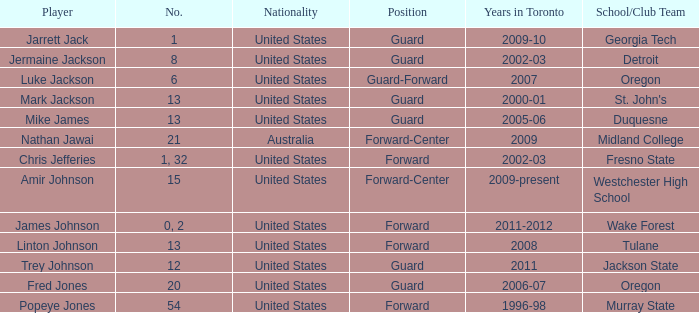What are the total amount of numbers on the Toronto team in 2005-06? 1.0. Could you parse the entire table as a dict? {'header': ['Player', 'No.', 'Nationality', 'Position', 'Years in Toronto', 'School/Club Team'], 'rows': [['Jarrett Jack', '1', 'United States', 'Guard', '2009-10', 'Georgia Tech'], ['Jermaine Jackson', '8', 'United States', 'Guard', '2002-03', 'Detroit'], ['Luke Jackson', '6', 'United States', 'Guard-Forward', '2007', 'Oregon'], ['Mark Jackson', '13', 'United States', 'Guard', '2000-01', "St. John's"], ['Mike James', '13', 'United States', 'Guard', '2005-06', 'Duquesne'], ['Nathan Jawai', '21', 'Australia', 'Forward-Center', '2009', 'Midland College'], ['Chris Jefferies', '1, 32', 'United States', 'Forward', '2002-03', 'Fresno State'], ['Amir Johnson', '15', 'United States', 'Forward-Center', '2009-present', 'Westchester High School'], ['James Johnson', '0, 2', 'United States', 'Forward', '2011-2012', 'Wake Forest'], ['Linton Johnson', '13', 'United States', 'Forward', '2008', 'Tulane'], ['Trey Johnson', '12', 'United States', 'Guard', '2011', 'Jackson State'], ['Fred Jones', '20', 'United States', 'Guard', '2006-07', 'Oregon'], ['Popeye Jones', '54', 'United States', 'Forward', '1996-98', 'Murray State']]} 